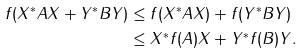<formula> <loc_0><loc_0><loc_500><loc_500>\| f ( X ^ { * } A X + Y ^ { * } B Y ) \| & \leq \| f ( X ^ { * } A X ) + f ( Y ^ { * } B Y ) \| \\ & \leq \| X ^ { * } f ( A ) X + Y ^ { * } f ( B ) Y \| .</formula> 